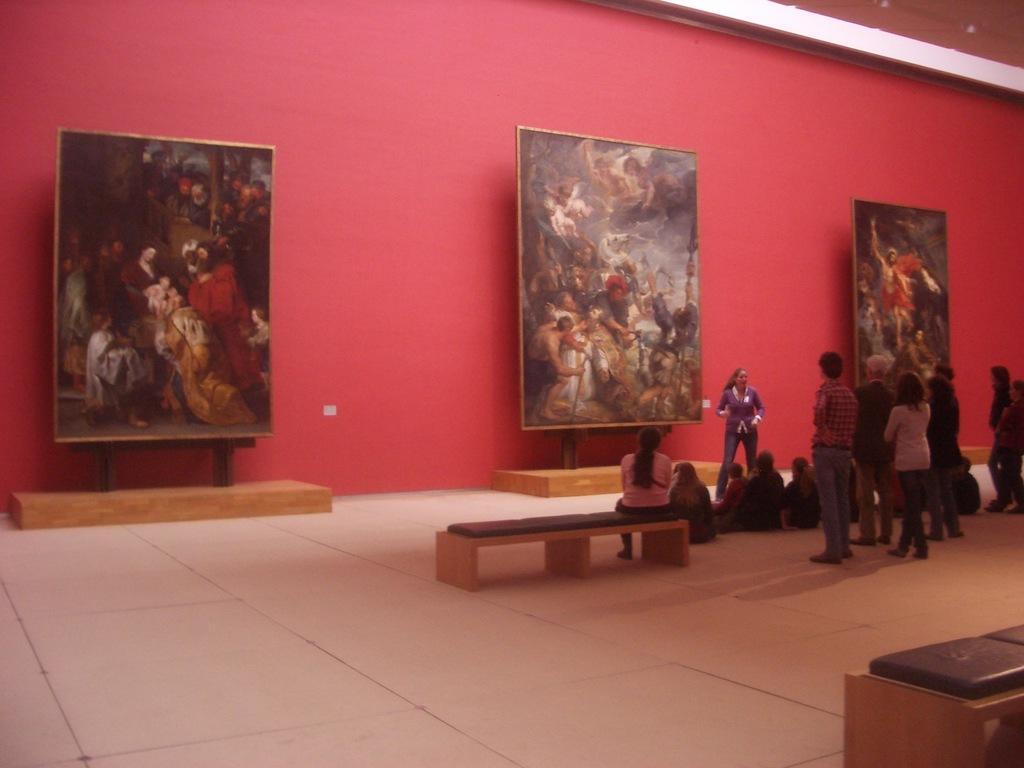In one or two sentences, can you explain what this image depicts? In the center of the image we can see benches, few people are standing and few people are sitting. And they are in different costumes. In the background there is a wall, three boards on the wooden objects and a few other objects. On the boards, we can see some painting, in which we can see a few people and a few other objects. 